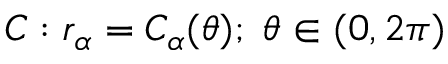Convert formula to latex. <formula><loc_0><loc_0><loc_500><loc_500>C \colon r _ { \alpha } = C _ { \alpha } ( \theta ) ; \, \theta \in ( 0 , 2 \pi )</formula> 